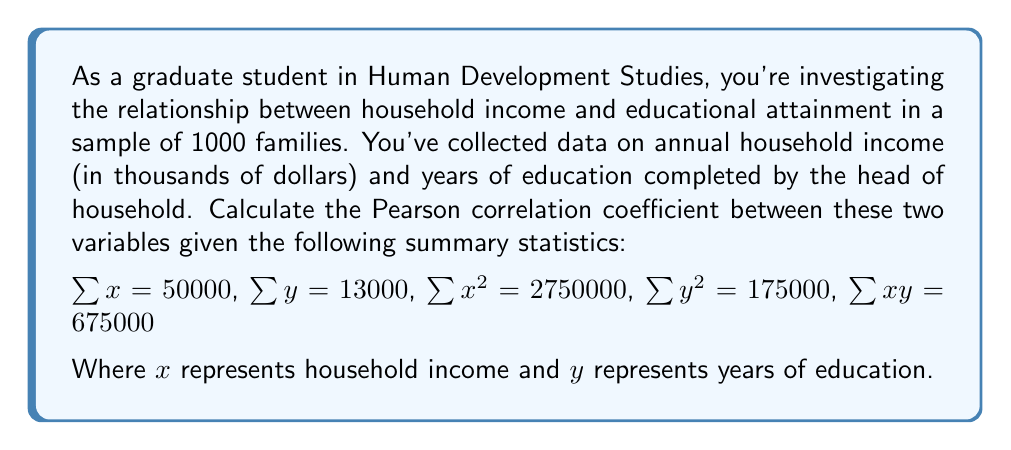What is the answer to this math problem? To calculate the Pearson correlation coefficient $(r)$, we'll use the formula:

$$r = \frac{n\sum xy - \sum x \sum y}{\sqrt{[n\sum x^2 - (\sum x)^2][n\sum y^2 - (\sum y)^2]}}$$

Where $n$ is the number of data points (1000 in this case).

Let's calculate each component:

1) $n\sum xy = 1000 \times 675000 = 675000000$

2) $\sum x \sum y = 50000 \times 13000 = 650000000$

3) $n\sum x^2 = 1000 \times 2750000 = 2750000000$

4) $(\sum x)^2 = 50000^2 = 2500000000$

5) $n\sum y^2 = 1000 \times 175000 = 175000000$

6) $(\sum y)^2 = 13000^2 = 169000000$

Now, let's substitute these values into the formula:

$$r = \frac{675000000 - 650000000}{\sqrt{[2750000000 - 2500000000][175000000 - 169000000]}}$$

$$r = \frac{25000000}{\sqrt{(250000000)(6000000)}}$$

$$r = \frac{25000000}{\sqrt{1500000000000000}}$$

$$r = \frac{25000000}{1224744.871}$$

$$r \approx 0.5715$$
Answer: The Pearson correlation coefficient between household income and educational attainment is approximately 0.5715. 